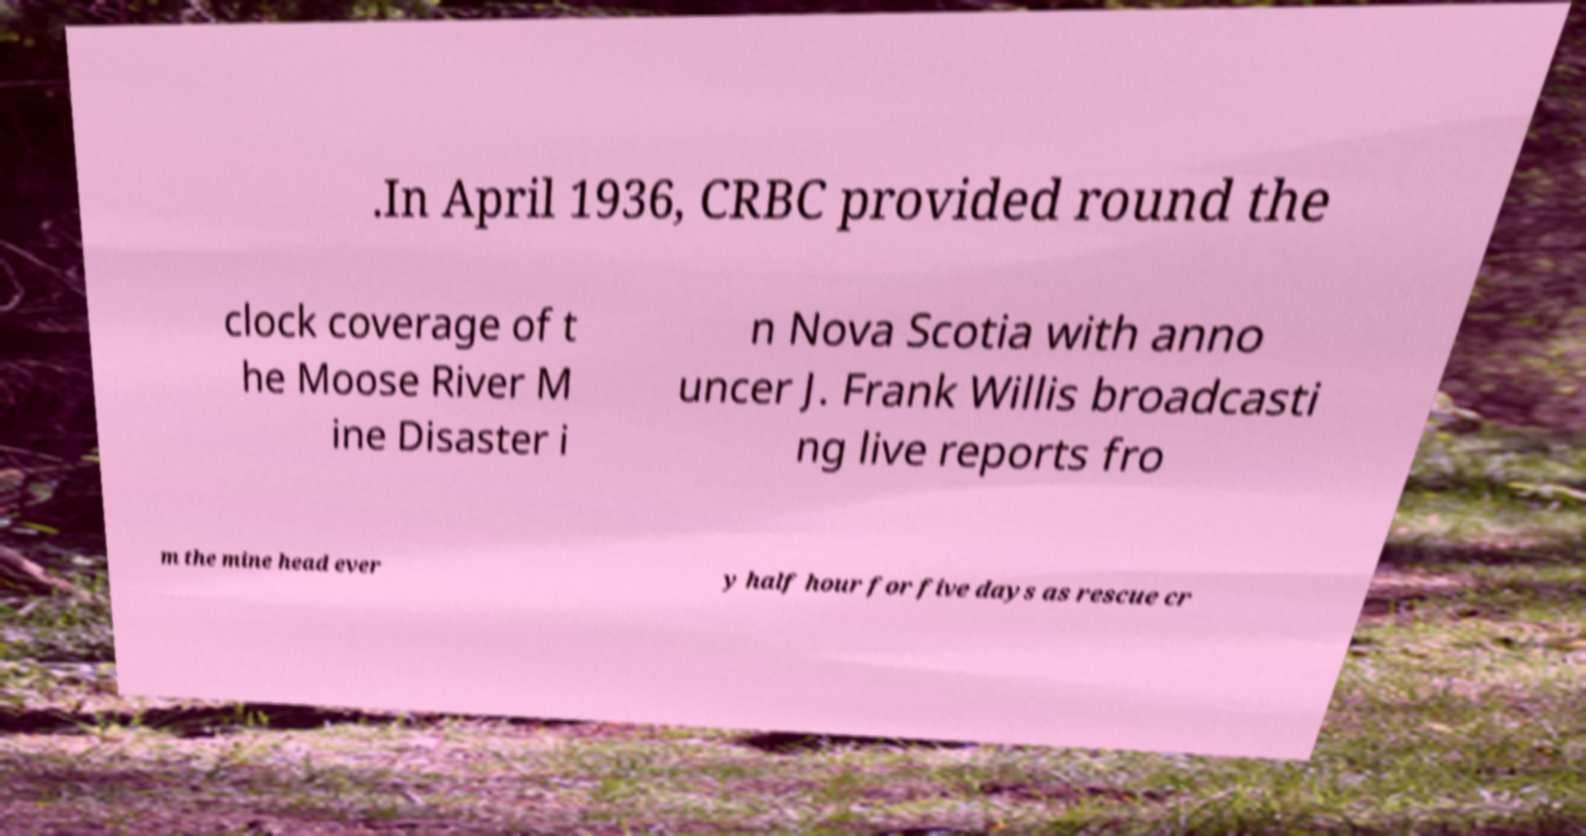I need the written content from this picture converted into text. Can you do that? .In April 1936, CRBC provided round the clock coverage of t he Moose River M ine Disaster i n Nova Scotia with anno uncer J. Frank Willis broadcasti ng live reports fro m the mine head ever y half hour for five days as rescue cr 